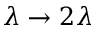<formula> <loc_0><loc_0><loc_500><loc_500>\lambda \to 2 \lambda</formula> 